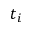Convert formula to latex. <formula><loc_0><loc_0><loc_500><loc_500>t _ { i }</formula> 